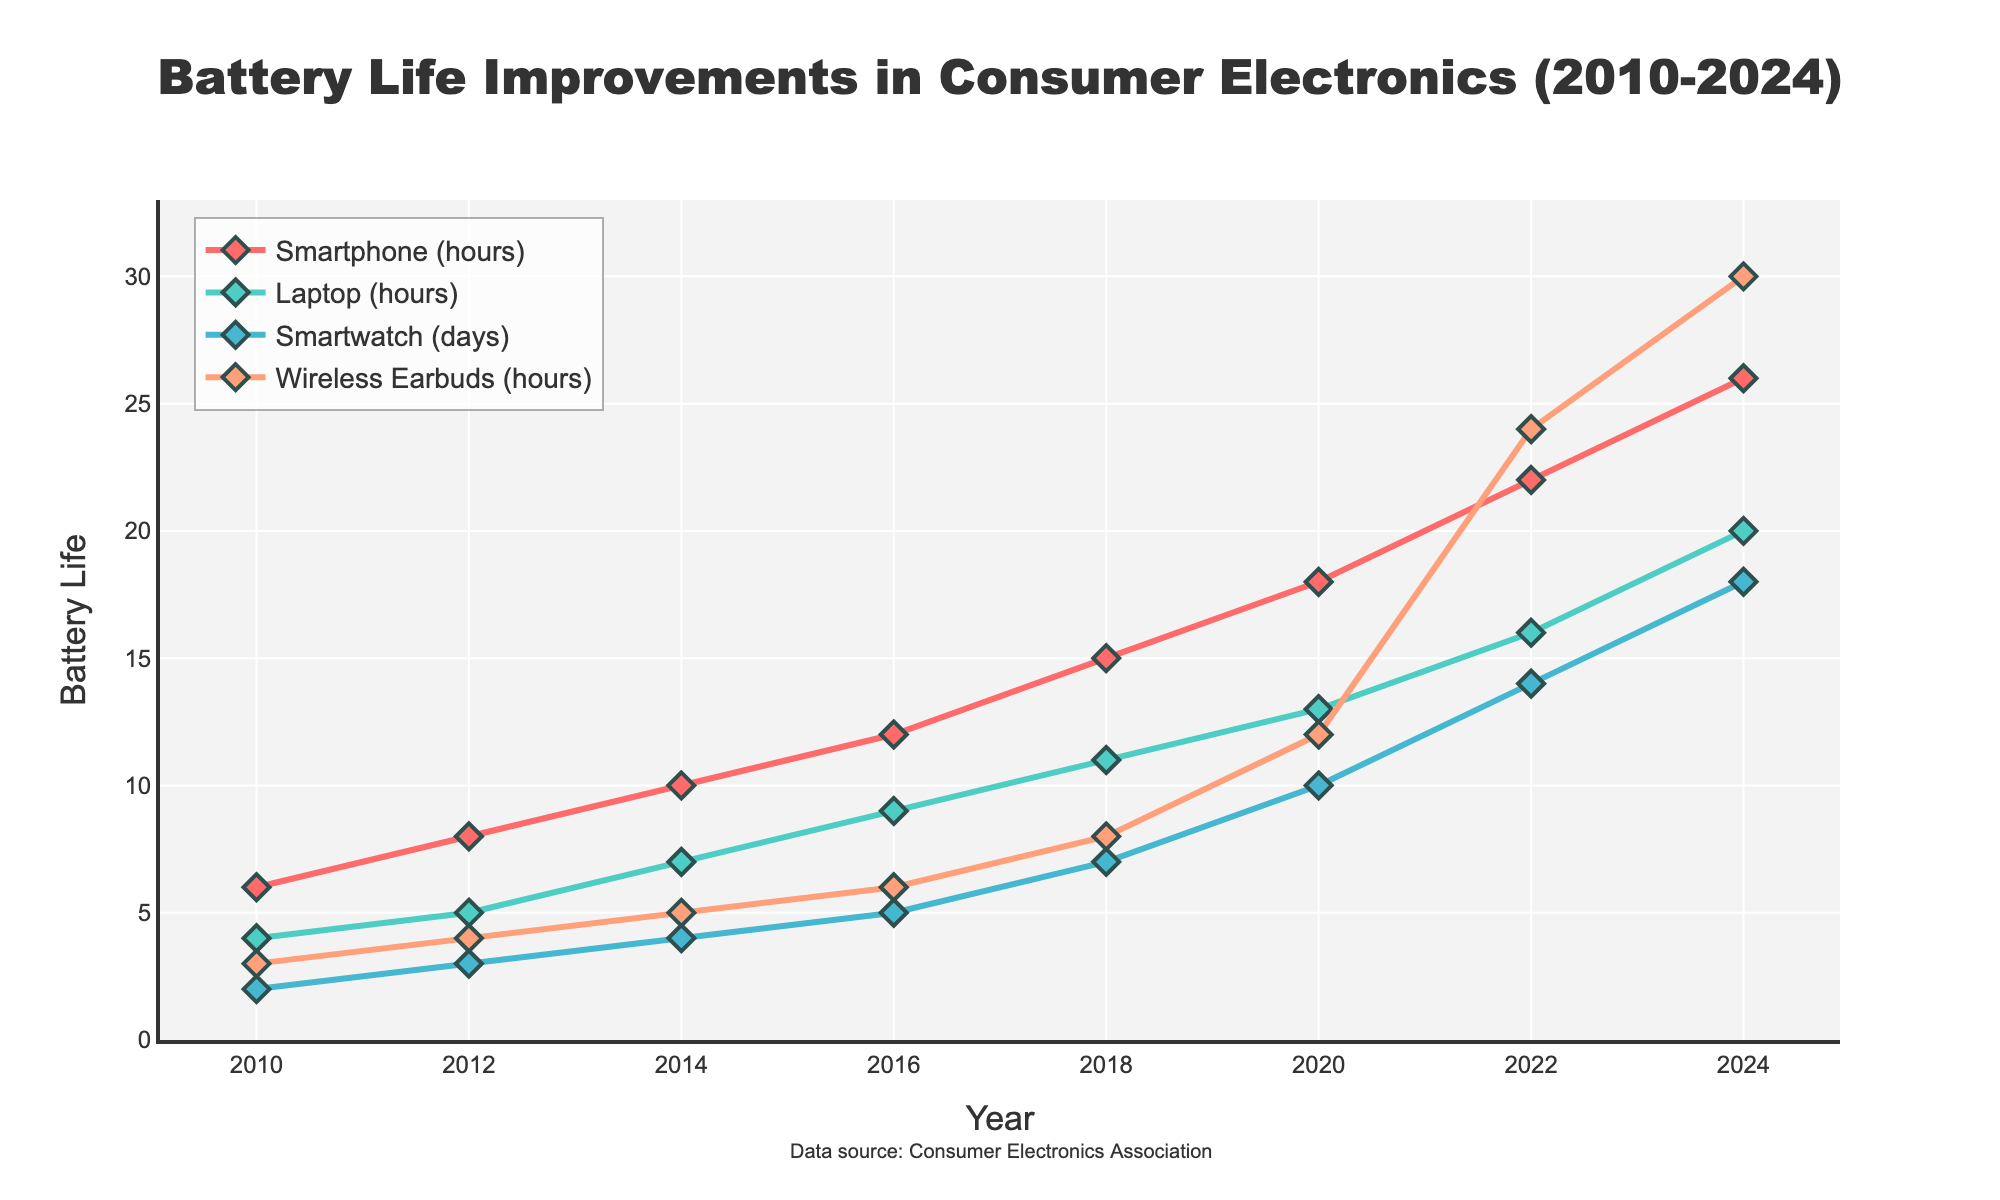What is the increase in battery life for smartphones from 2010 to 2024? To find the increase, subtract the battery life of smartphones in 2010 from that in 2024: 26 hours (2024) - 6 hours (2010) = 20 hours
Answer: 20 hours Which device showed the most improvement in battery life between 2010 and 2024? To determine which device showed the most improvement, calculate the battery life increase for each device and compare: Smartphone: 26-6=20 hours, Laptop: 20-4=16 hours, Smartwatch: 18-2=16 days, Wireless Earbuds: 30-3=27 hours. Wireless Earbuds showed the most improvement.
Answer: Wireless Earbuds In what year did smartwatches' battery life reach 10 days? Find the year where the smartwatch trend line intersects 10 days: This occurs in the year 2020 according to the data.
Answer: 2020 What is the total battery life for laptops and wireless earbuds in 2024? Add the battery life of laptops and wireless earbuds in 2024: 20 hours (laptops) + 30 hours (wireless earbuds) = 50 hours
Answer: 50 hours Did laptops ever exceed smartphones in battery life from 2010 to 2024? Compare the battery life trends of laptops and smartphones over the years. Laptops always had lower battery life than smartphones throughout the period.
Answer: No Between 2016 and 2020, which device experienced the greatest battery life improvement? Calculate the improvement for each device between 2016 and 2020: Smartphone: 18-12=6 hours, Laptop: 13-9=4 hours, Smartwatch: 10-5=5 days, Wireless Earbuds: 12-6=6 hours. The largest improvement was for both smartphones and wireless earbuds.
Answer: Smartphones and Wireless Earbuds (tie) What was the average battery life of smartwatches over the entire period from 2010 to 2024? Calculate the average of smartwatch battery life values over the years: (2 + 3 + 4 + 5 + 7 + 10 + 14 + 18) / 8 = 7.875 days
Answer: 7.875 days Which device had the least battery life improvement between 2012 and 2016? Compute the battery life increase for each device from 2012 to 2016: Smartphone: 12-8=4 hours, Laptop: 9-5=4 hours, Smartwatch: 5-3=2 days, Wireless Earbuds: 6-4=2 hours. Smartwatches and Wireless Earbuds had the least improvement.
Answer: Smartwatches and Wireless Earbuds (tie) By how much did the battery life of laptops increase from 2012 to 2022? Calculate the increase in battery life for laptops between 2012 and 2022: 16 hours (2022) - 5 hours (2012) = 11 hours
Answer: 11 hours What was the battery life for wireless earbuds in 2018 and how did it compare visually to the battery life of other devices in the same year? Locate the 2018 battery life for wireless earbuds and compare each device's value visually: Wireless Earbuds: 8 hours, Smartphones: 15 hours, Laptops: 11 hours, Smartwatches: 7 days. Wireless Earbuds' battery life was substantially lower than smartphones but similar to laptops.
Answer: 8 hours, lower than smartphones, similar to laptops 